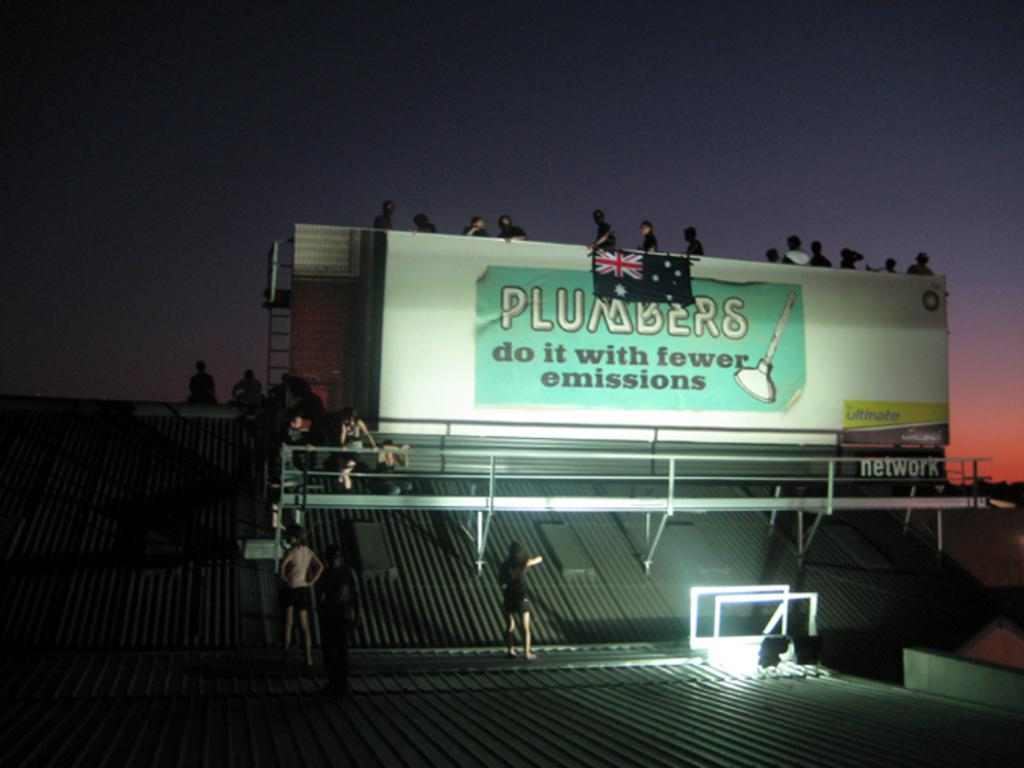<image>
Present a compact description of the photo's key features. A billboard that has "PLUMBERS do it with fewer emissions" is illuminated at night with people standing around it. 